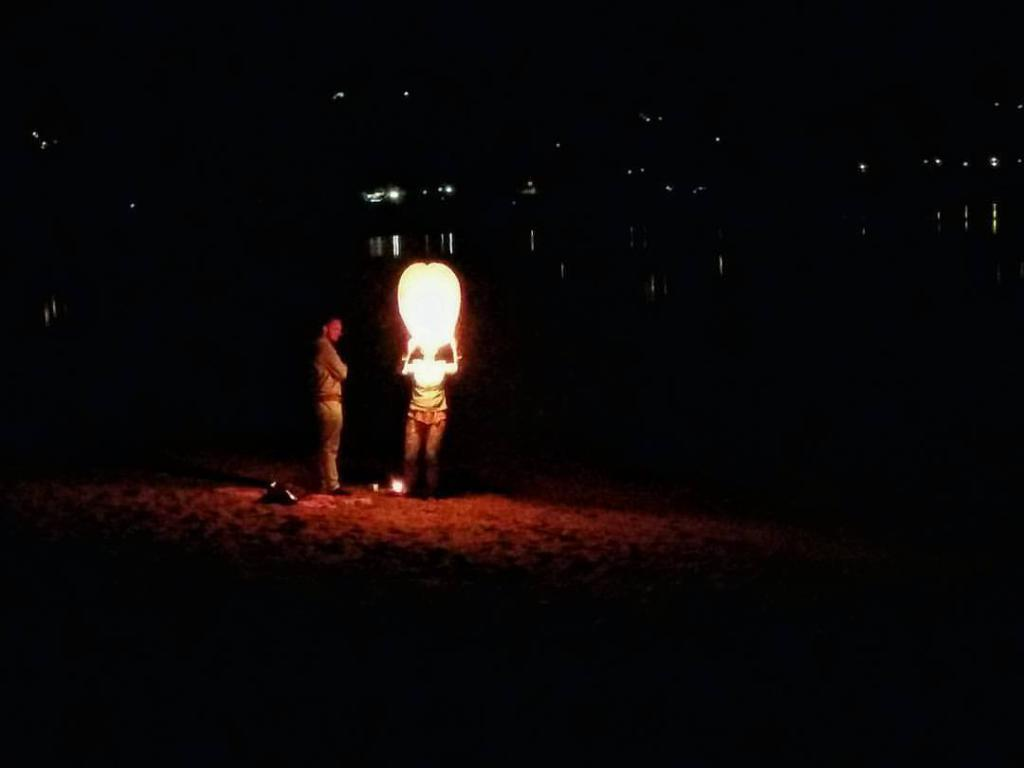How many people are in the image? There are two persons standing in the image. What is the person on the right holding? The person on the right is holding a sky lantern. What can be observed about the background of the image? The background of the image is dark. What is the process of folding the sky lantern in the image? There is no process of folding the sky lantern in the image, as the person on the right is already holding it unfolded. 